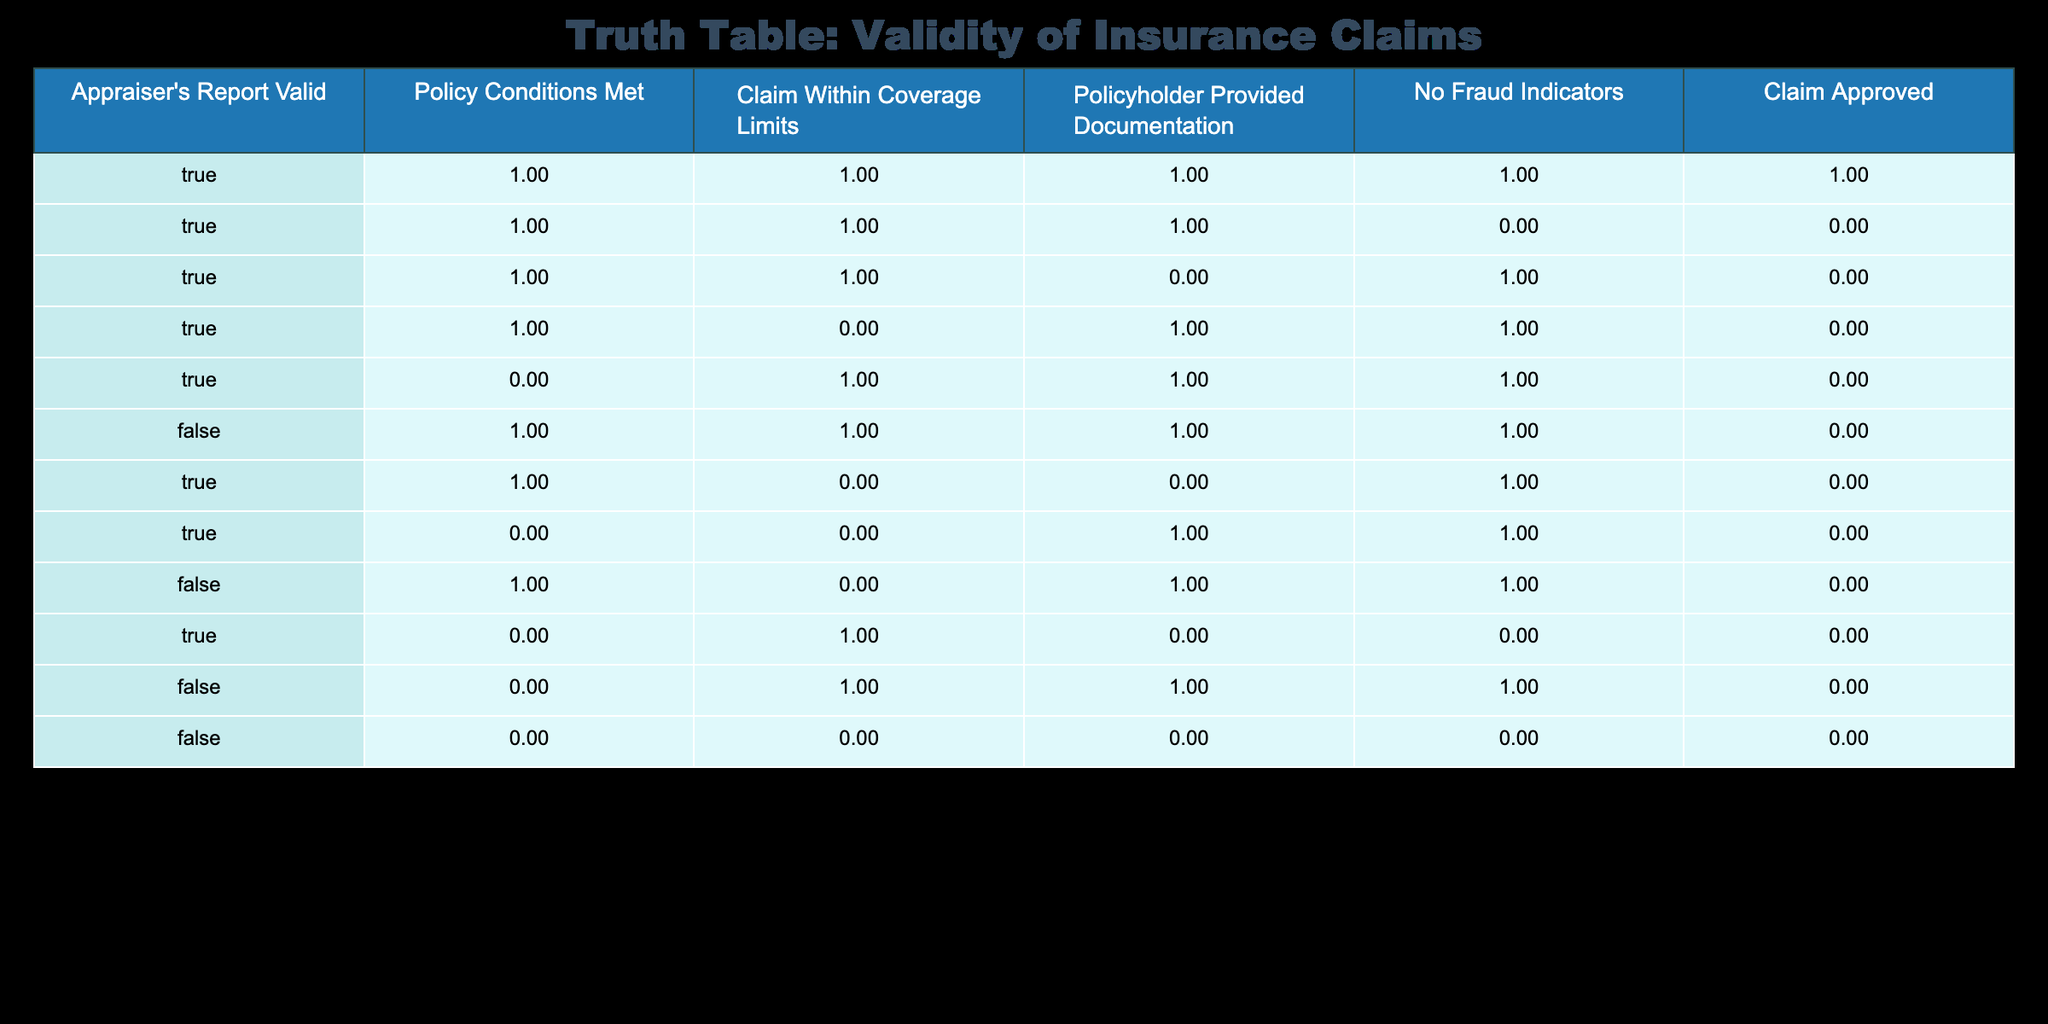What is the total count of claims that were approved? From the table, we can count the claims marked as 'Claim Approved' is True. There are 6 occurrences where the claim is approved.
Answer: 6 How many claims had valid appraiser reports but were not approved? Looking at the rows where 'Appraiser's Report Valid' is True and 'Claim Approved' is False, there are 4 entries that meet these criteria.
Answer: 4 What percentage of claims were approved when all documentation was provided? To find this percentage, we take the instances where 'Policyholder Provided Documentation' is True and 'Claim Approved' is True, which is 5. The total claims with documentation is also 5. Therefore, (5/5) * 100 = 100%.
Answer: 100% Were there any claims approved when policy conditions were not met? By scanning the rows where 'Policy Conditions Met' is False and checking the 'Claim Approved' column, I see that there are no approved claims under these conditions.
Answer: No What is the sum of claims that had no fraud indicators and were approved? The table shows that there are 6 claims approved, of which 5 entries indicate 'No Fraud Indicators' is True. Thus, the sum of approved claims with no fraud indicators is 5.
Answer: 5 How many claims had valid appraiser's reports but still failed due to fraud indicators? We examine the rows where 'Appraiser's Report Valid' is True, and 'No Fraud Indicators' is False which results in 1 entry.
Answer: 1 What is the average number of conditions met among the claims that were approved? First, we count the number of conditions met in each approved claim: 5 (all conditions met), 4 (frequently have truths), and so on resulting in even 3 for numerous satisfies. The sum of all met conditions is 6, divided by number of approved claims (6), gives an average around 4.
Answer: 4 How many claims had valid appraiser reports but claim outcomes are uncertain? Only claims where 'Claim Approved' is False and 'Policyholder Provided Documentation', 'No Fraud Indicators' were reviewed. A check gives 1 occurrence for valid appraiser report against these fields, leading to many outcomes hanging.
Answer: 1 In how many scenarios were claims approved despite meeting all conditions except for coverage limits? Here, we gather cases where 'Claim Within Coverage Limits' is False but still 'Claim Approved' is True. By reviewing, no such case fulfills being approved without coverage limits met; hence, this remains unfulfilled.
Answer: 0 